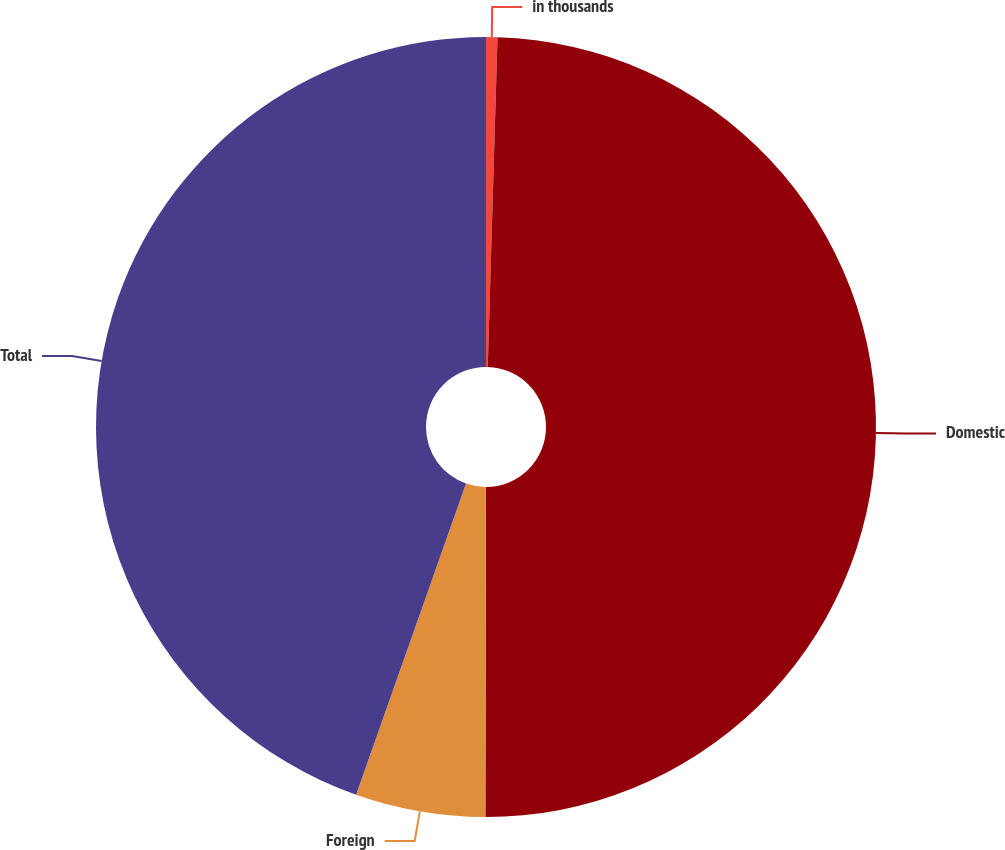<chart> <loc_0><loc_0><loc_500><loc_500><pie_chart><fcel>in thousands<fcel>Domestic<fcel>Foreign<fcel>Total<nl><fcel>0.47%<fcel>49.56%<fcel>5.38%<fcel>44.6%<nl></chart> 